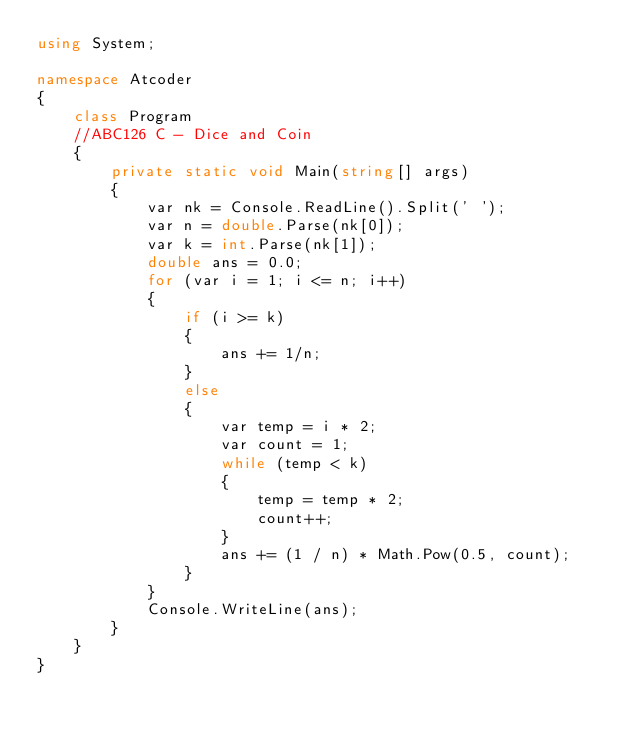<code> <loc_0><loc_0><loc_500><loc_500><_C#_>using System;

namespace Atcoder
{
    class Program
    //ABC126 C - Dice and Coin
    {
        private static void Main(string[] args)
        {
            var nk = Console.ReadLine().Split(' ');
            var n = double.Parse(nk[0]);
            var k = int.Parse(nk[1]);
            double ans = 0.0;
            for (var i = 1; i <= n; i++)
            {
                if (i >= k)
                {
                    ans += 1/n;
                }
                else
                {
                    var temp = i * 2;
                    var count = 1;
                    while (temp < k)
                    {
                        temp = temp * 2;
                        count++;
                    }
                    ans += (1 / n) * Math.Pow(0.5, count);
                }
            }
            Console.WriteLine(ans);
        }
    }
}
</code> 